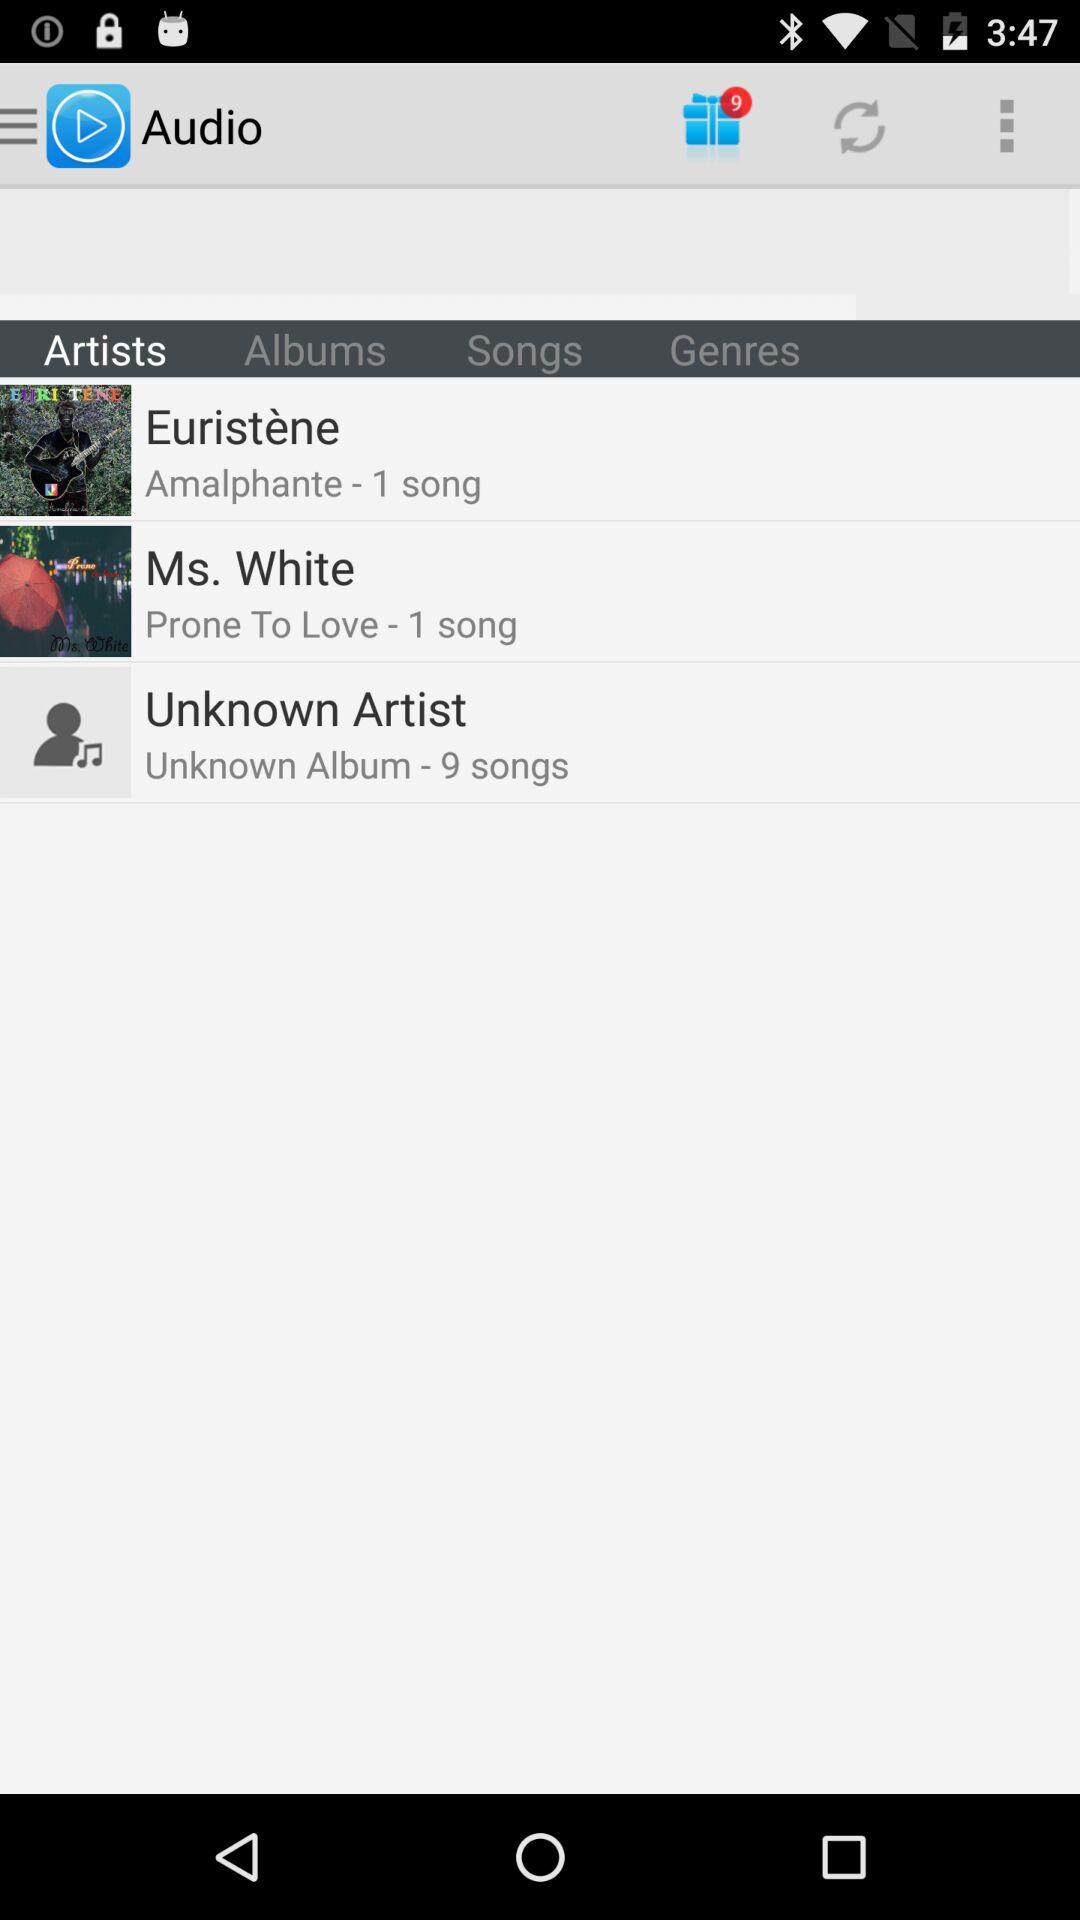What is the artist name of the song "Prone To Love"? The artist name of the song "Prone To Love" is Ms. White. 